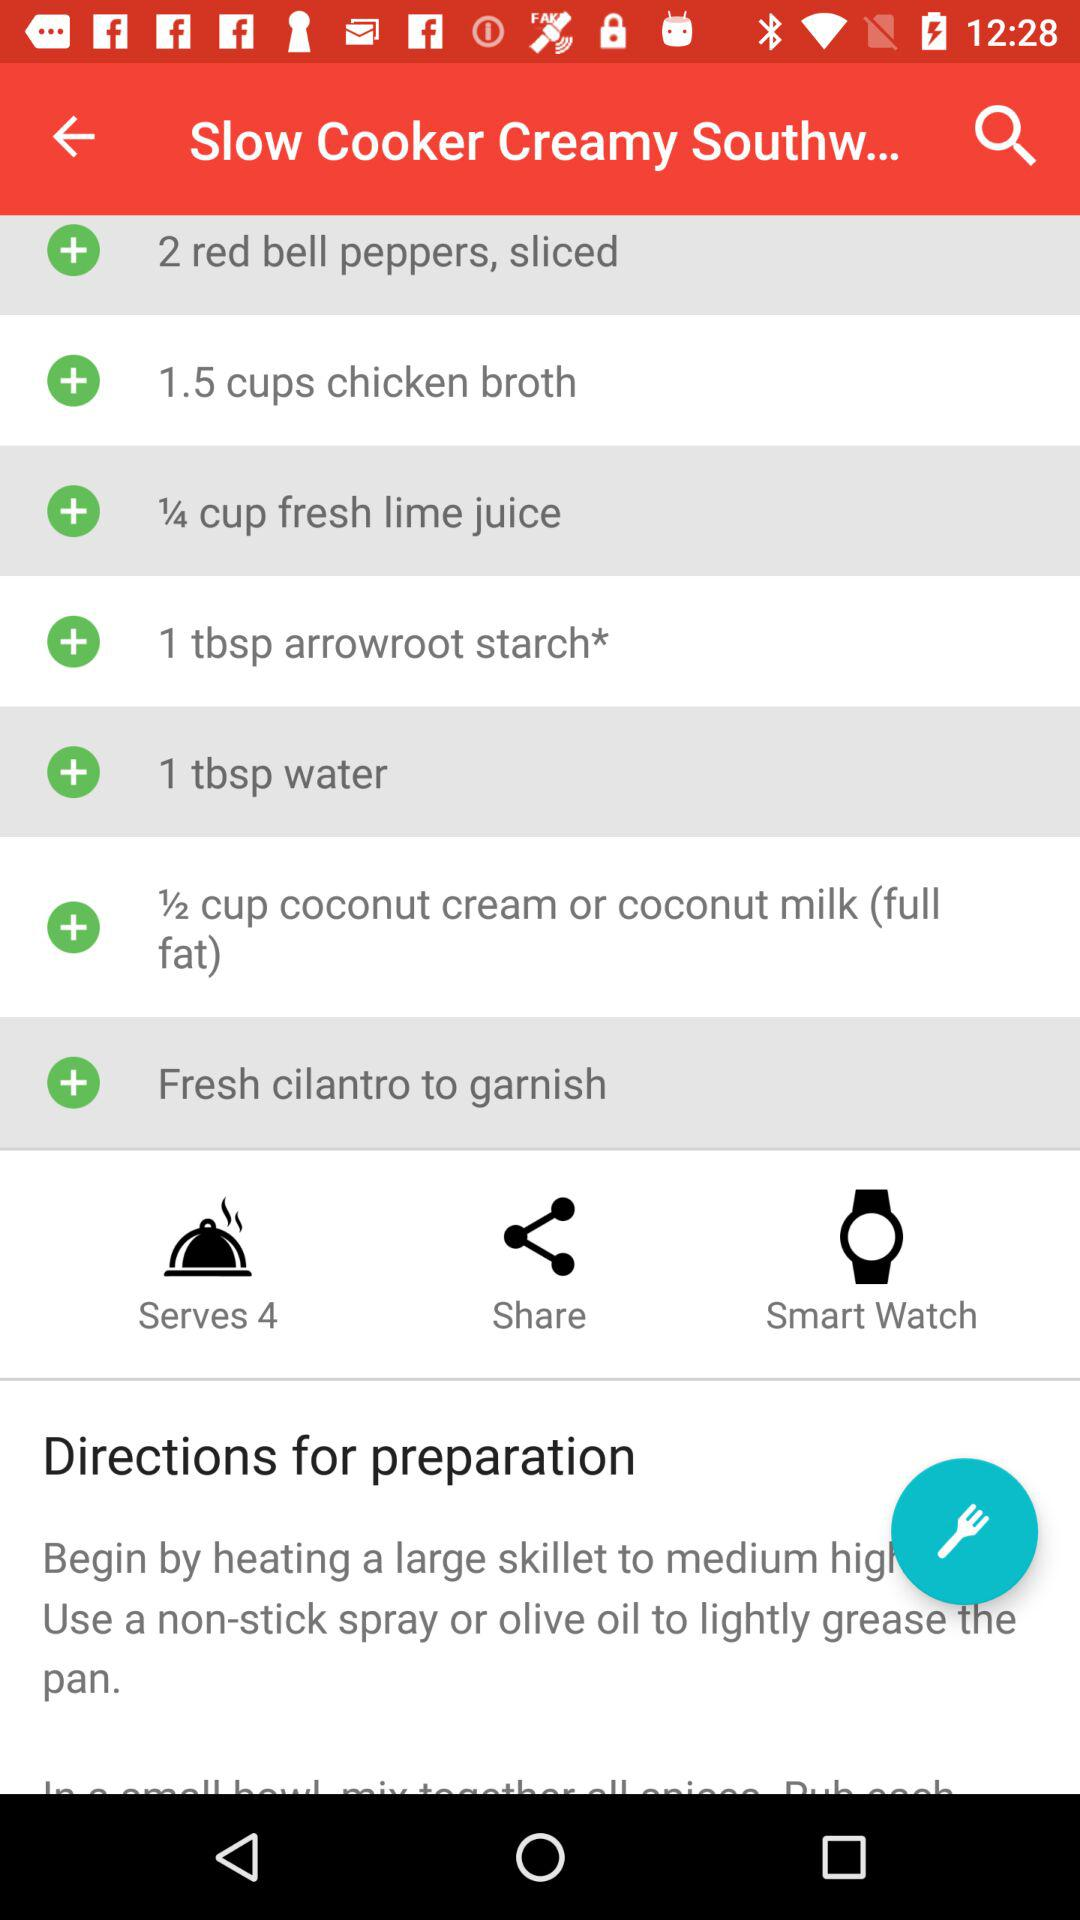What ingredient is used for garnishing? The ingredient that is used for garnishing is fresh cilantro. 